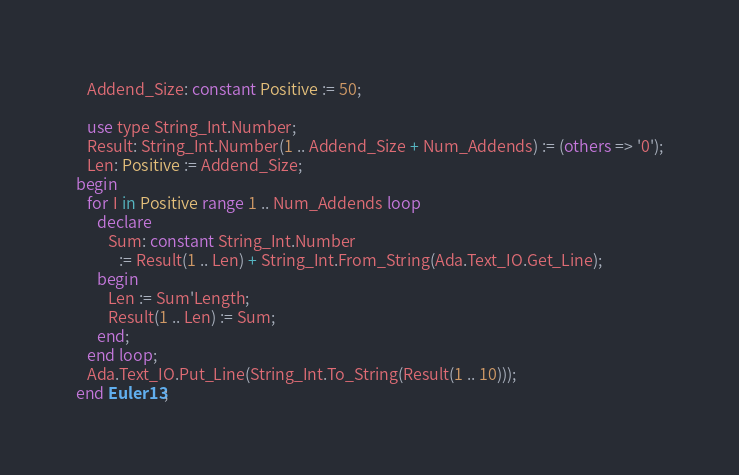Convert code to text. <code><loc_0><loc_0><loc_500><loc_500><_Ada_>   Addend_Size: constant Positive := 50;

   use type String_Int.Number;
   Result: String_Int.Number(1 .. Addend_Size + Num_Addends) := (others => '0');
   Len: Positive := Addend_Size;
begin
   for I in Positive range 1 .. Num_Addends loop
      declare
         Sum: constant String_Int.Number
            := Result(1 .. Len) + String_Int.From_String(Ada.Text_IO.Get_Line);
      begin
         Len := Sum'Length;
         Result(1 .. Len) := Sum;
      end;
   end loop;
   Ada.Text_IO.Put_Line(String_Int.To_String(Result(1 .. 10)));
end Euler13;
</code> 